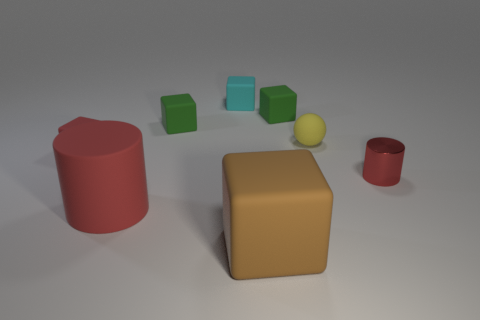Subtract 2 blocks. How many blocks are left? 3 Subtract all brown matte blocks. How many blocks are left? 4 Subtract all blue balls. Subtract all purple blocks. How many balls are left? 1 Add 1 yellow metallic things. How many objects exist? 9 Subtract all balls. How many objects are left? 7 Subtract all large blue metal spheres. Subtract all red matte things. How many objects are left? 6 Add 8 red cylinders. How many red cylinders are left? 10 Add 6 big rubber balls. How many big rubber balls exist? 6 Subtract 0 red balls. How many objects are left? 8 